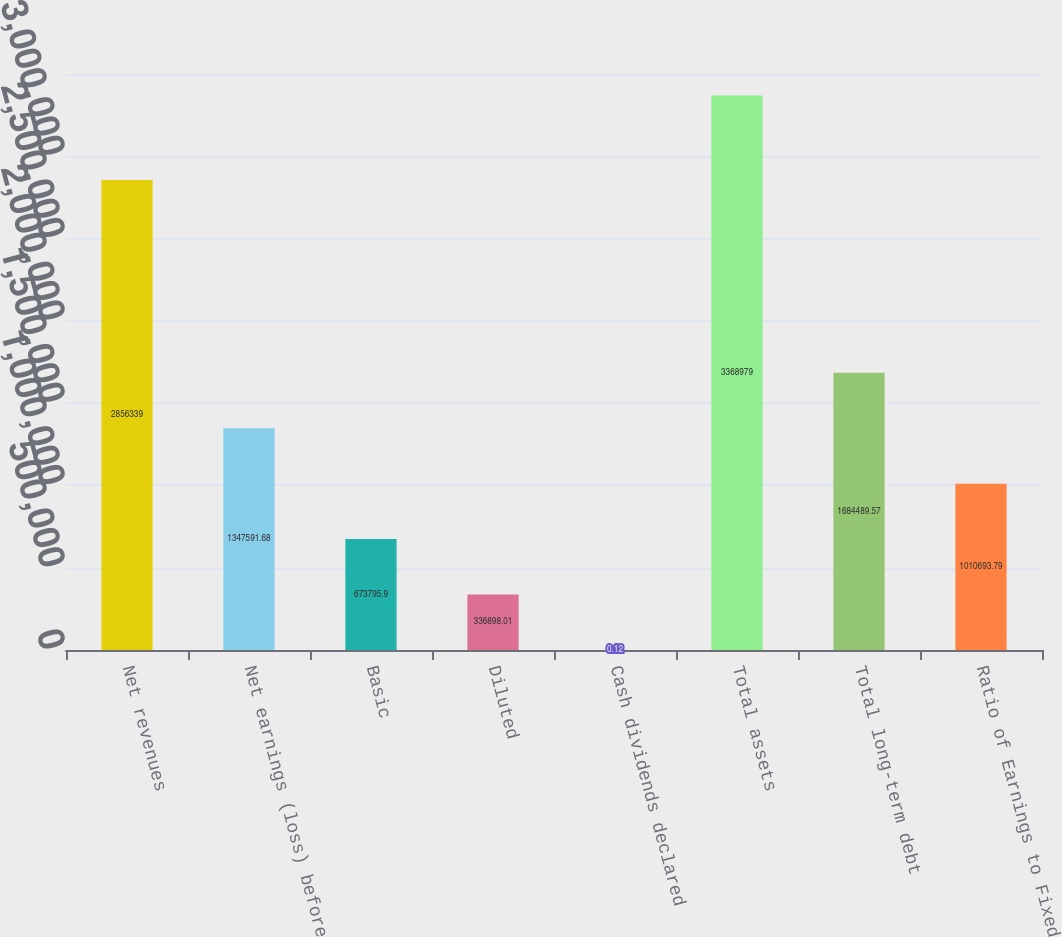<chart> <loc_0><loc_0><loc_500><loc_500><bar_chart><fcel>Net revenues<fcel>Net earnings (loss) before<fcel>Basic<fcel>Diluted<fcel>Cash dividends declared<fcel>Total assets<fcel>Total long-term debt<fcel>Ratio of Earnings to Fixed<nl><fcel>2.85634e+06<fcel>1.34759e+06<fcel>673796<fcel>336898<fcel>0.12<fcel>3.36898e+06<fcel>1.68449e+06<fcel>1.01069e+06<nl></chart> 